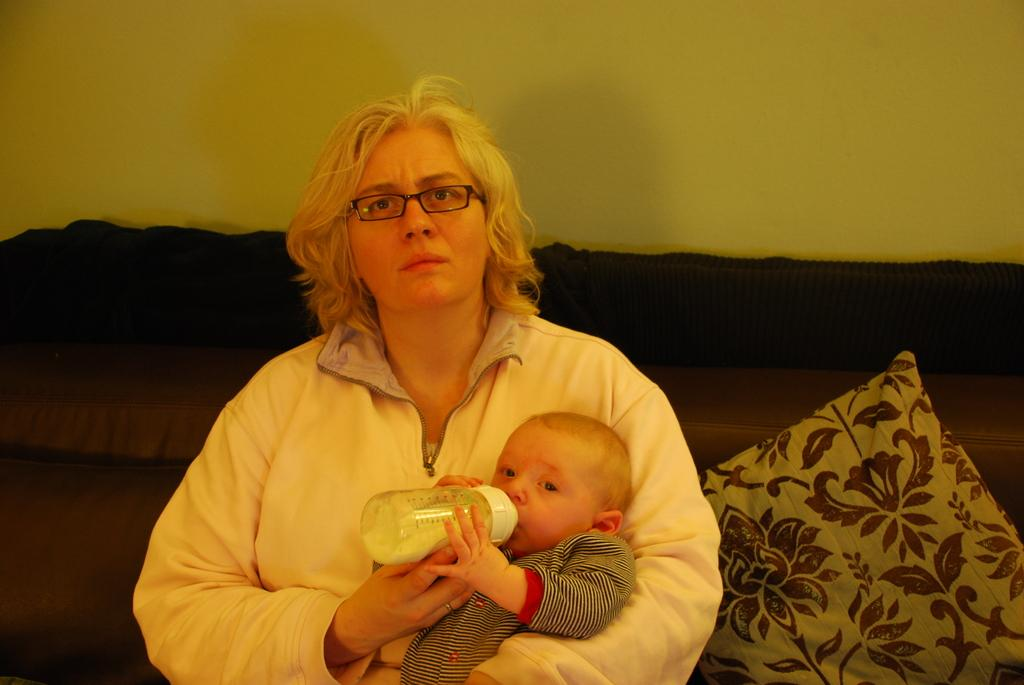Who is the main subject in the image? There is a woman in the image. What is the woman doing in the image? The woman is carrying a baby. What is the baby doing in the image? The baby is drinking milk from a bottle. Where are the woman and baby located in the image? The woman and baby are on a sofa. What else can be seen on the sofa? There is a pillow on the sofa. What is visible in the background of the image? There is a wall visible in the background of the image. What type of meeting is taking place in the image? There is no meeting present in the image; it features a woman carrying a baby on a sofa. What is the texture of the baby's clothing in the image? The texture of the baby's clothing cannot be determined from the image. 